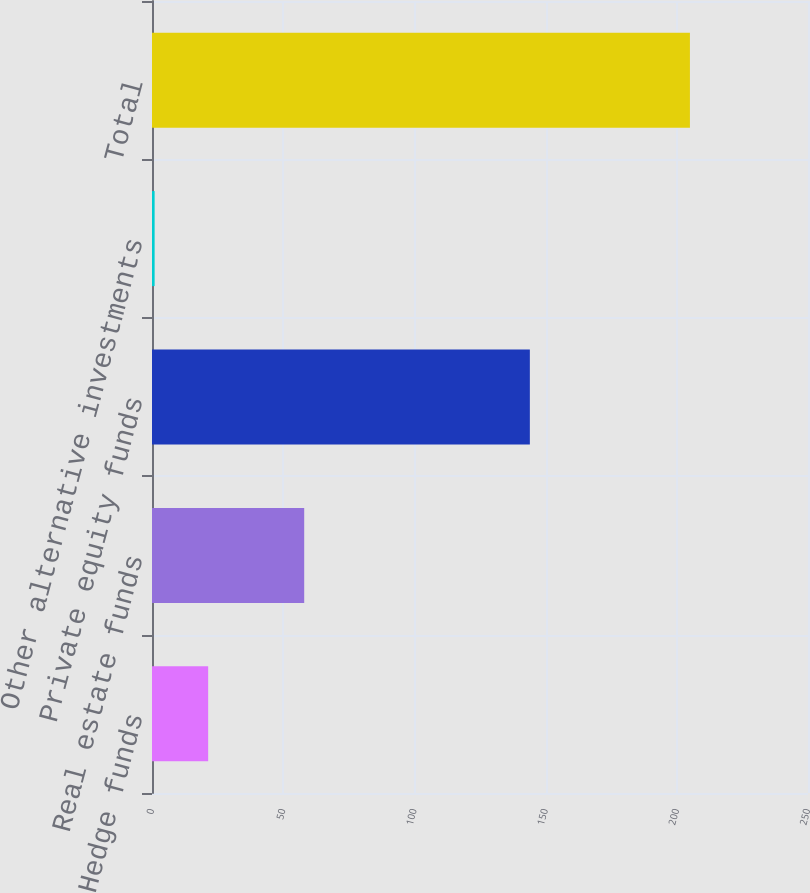Convert chart. <chart><loc_0><loc_0><loc_500><loc_500><bar_chart><fcel>Hedge funds<fcel>Real estate funds<fcel>Private equity funds<fcel>Other alternative investments<fcel>Total<nl><fcel>21.4<fcel>58<fcel>144<fcel>1<fcel>205<nl></chart> 